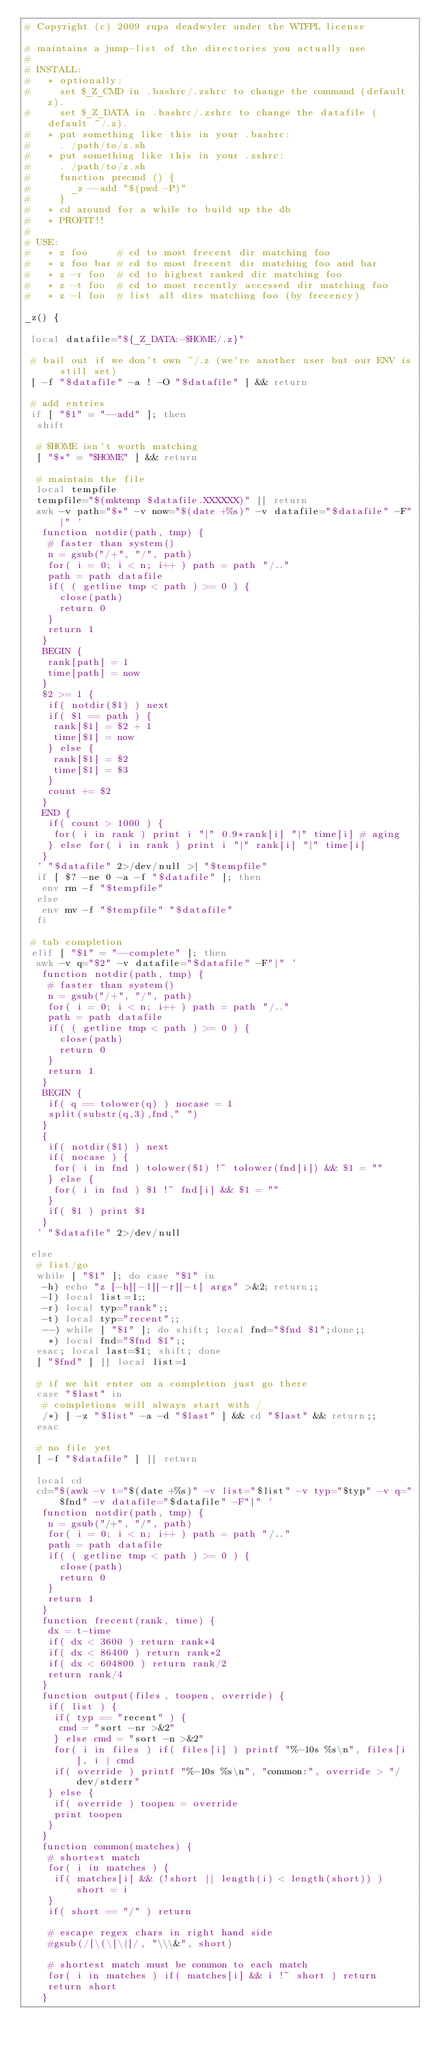Convert code to text. <code><loc_0><loc_0><loc_500><loc_500><_Bash_># Copyright (c) 2009 rupa deadwyler under the WTFPL license

# maintains a jump-list of the directories you actually use
#
# INSTALL:
#   * optionally:
#     set $_Z_CMD in .bashrc/.zshrc to change the command (default z).
#     set $_Z_DATA in .bashrc/.zshrc to change the datafile (default ~/.z).
#   * put something like this in your .bashrc:
#     . /path/to/z.sh
#   * put something like this in your .zshrc:
#     . /path/to/z.sh
#     function precmd () {
#       _z --add "$(pwd -P)"
#     }
#   * cd around for a while to build up the db
#   * PROFIT!!
#
# USE:
#   * z foo     # cd to most frecent dir matching foo
#   * z foo bar # cd to most frecent dir matching foo and bar
#   * z -r foo  # cd to highest ranked dir matching foo
#   * z -t foo  # cd to most recently accessed dir matching foo
#   * z -l foo  # list all dirs matching foo (by frecency)

_z() {

 local datafile="${_Z_DATA:-$HOME/.z}"

 # bail out if we don't own ~/.z (we're another user but our ENV is still set)
 [ -f "$datafile" -a ! -O "$datafile" ] && return

 # add entries
 if [ "$1" = "--add" ]; then
  shift

  # $HOME isn't worth matching
  [ "$*" = "$HOME" ] && return

  # maintain the file
  local tempfile
  tempfile="$(mktemp $datafile.XXXXXX)" || return
  awk -v path="$*" -v now="$(date +%s)" -v datafile="$datafile" -F"|" '
   function notdir(path, tmp) {
    # faster than system()
    n = gsub("/+", "/", path)
    for( i = 0; i < n; i++ ) path = path "/.."
    path = path datafile
    if( ( getline tmp < path ) >= 0 ) {
      close(path)
      return 0
    }
    return 1
   }
   BEGIN {
    rank[path] = 1
    time[path] = now
   }
   $2 >= 1 {
    if( notdir($1) ) next
    if( $1 == path ) {
     rank[$1] = $2 + 1
     time[$1] = now
    } else {
     rank[$1] = $2
     time[$1] = $3
    }
    count += $2
   }
   END {
    if( count > 1000 ) {
     for( i in rank ) print i "|" 0.9*rank[i] "|" time[i] # aging
    } else for( i in rank ) print i "|" rank[i] "|" time[i]
   }
  ' "$datafile" 2>/dev/null >| "$tempfile"
  if [ $? -ne 0 -a -f "$datafile" ]; then
   env rm -f "$tempfile"
  else
   env mv -f "$tempfile" "$datafile"
  fi

 # tab completion
 elif [ "$1" = "--complete" ]; then
  awk -v q="$2" -v datafile="$datafile" -F"|" '
   function notdir(path, tmp) {
    # faster than system()
    n = gsub("/+", "/", path)
    for( i = 0; i < n; i++ ) path = path "/.."
    path = path datafile
    if( ( getline tmp < path ) >= 0 ) {
      close(path)
      return 0
    }
    return 1
   }
   BEGIN {
    if( q == tolower(q) ) nocase = 1
    split(substr(q,3),fnd," ")
   }
   {
    if( notdir($1) ) next
    if( nocase ) {
     for( i in fnd ) tolower($1) !~ tolower(fnd[i]) && $1 = ""
    } else {
     for( i in fnd ) $1 !~ fnd[i] && $1 = ""
    }
    if( $1 ) print $1
   }
  ' "$datafile" 2>/dev/null

 else
  # list/go
  while [ "$1" ]; do case "$1" in
   -h) echo "z [-h][-l][-r][-t] args" >&2; return;;
   -l) local list=1;;
   -r) local typ="rank";;
   -t) local typ="recent";;
   --) while [ "$1" ]; do shift; local fnd="$fnd $1";done;;
    *) local fnd="$fnd $1";;
  esac; local last=$1; shift; done
  [ "$fnd" ] || local list=1

  # if we hit enter on a completion just go there
  case "$last" in
   # completions will always start with /
   /*) [ -z "$list" -a -d "$last" ] && cd "$last" && return;;
  esac

  # no file yet
  [ -f "$datafile" ] || return

  local cd
  cd="$(awk -v t="$(date +%s)" -v list="$list" -v typ="$typ" -v q="$fnd" -v datafile="$datafile" -F"|" '
   function notdir(path, tmp) {
    n = gsub("/+", "/", path)
    for( i = 0; i < n; i++ ) path = path "/.."
    path = path datafile
    if( ( getline tmp < path ) >= 0 ) {
      close(path)
      return 0
    }
    return 1
   }
   function frecent(rank, time) {
    dx = t-time
    if( dx < 3600 ) return rank*4
    if( dx < 86400 ) return rank*2
    if( dx < 604800 ) return rank/2
    return rank/4
   }
   function output(files, toopen, override) {
    if( list ) {
     if( typ == "recent" ) {
      cmd = "sort -nr >&2"
     } else cmd = "sort -n >&2"
     for( i in files ) if( files[i] ) printf "%-10s %s\n", files[i], i | cmd
     if( override ) printf "%-10s %s\n", "common:", override > "/dev/stderr"
    } else {
     if( override ) toopen = override
     print toopen
    }
   }
   function common(matches) {
    # shortest match
    for( i in matches ) {
     if( matches[i] && (!short || length(i) < length(short)) ) short = i
    }
    if( short == "/" ) return

    # escape regex chars in right hand side
    #gsub(/[\(\[\|]/, "\\\&", short)

    # shortest match must be common to each match
    for( i in matches ) if( matches[i] && i !~ short ) return
    return short
   }</code> 